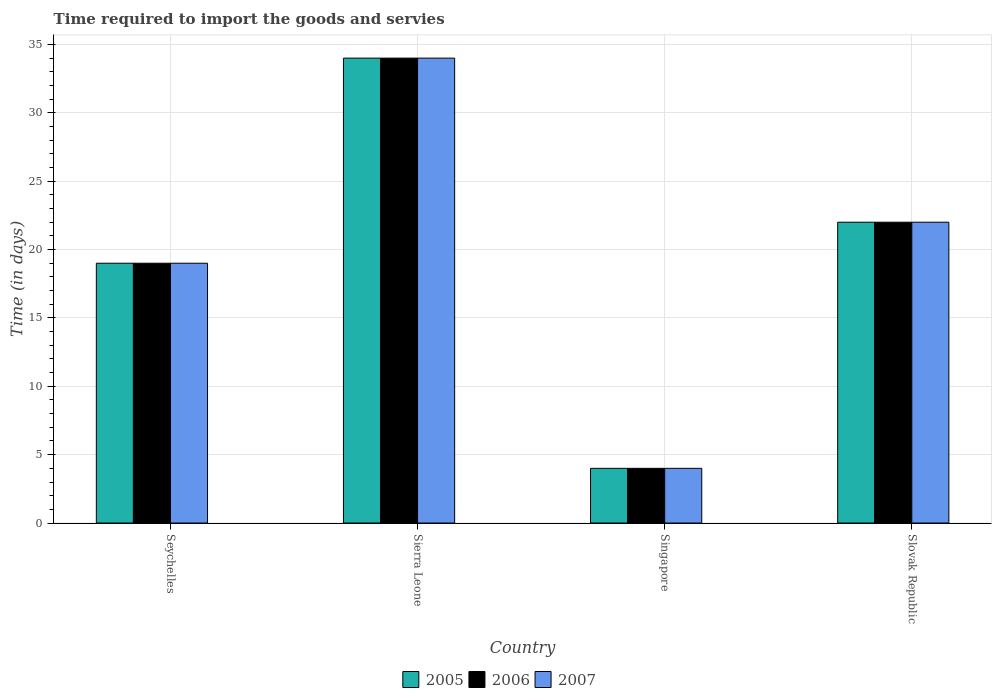How many different coloured bars are there?
Keep it short and to the point. 3. How many groups of bars are there?
Give a very brief answer. 4. Are the number of bars on each tick of the X-axis equal?
Provide a short and direct response. Yes. How many bars are there on the 4th tick from the left?
Your response must be concise. 3. How many bars are there on the 2nd tick from the right?
Offer a terse response. 3. What is the label of the 1st group of bars from the left?
Provide a short and direct response. Seychelles. What is the number of days required to import the goods and services in 2006 in Seychelles?
Provide a short and direct response. 19. Across all countries, what is the maximum number of days required to import the goods and services in 2005?
Ensure brevity in your answer.  34. In which country was the number of days required to import the goods and services in 2005 maximum?
Provide a succinct answer. Sierra Leone. In which country was the number of days required to import the goods and services in 2006 minimum?
Give a very brief answer. Singapore. What is the total number of days required to import the goods and services in 2006 in the graph?
Provide a succinct answer. 79. What is the difference between the number of days required to import the goods and services in 2007 in Sierra Leone and that in Slovak Republic?
Ensure brevity in your answer.  12. What is the average number of days required to import the goods and services in 2005 per country?
Provide a short and direct response. 19.75. What is the difference between the number of days required to import the goods and services of/in 2006 and number of days required to import the goods and services of/in 2007 in Slovak Republic?
Offer a very short reply. 0. In how many countries, is the number of days required to import the goods and services in 2006 greater than 10 days?
Give a very brief answer. 3. What is the ratio of the number of days required to import the goods and services in 2006 in Singapore to that in Slovak Republic?
Offer a terse response. 0.18. Is the difference between the number of days required to import the goods and services in 2006 in Seychelles and Slovak Republic greater than the difference between the number of days required to import the goods and services in 2007 in Seychelles and Slovak Republic?
Make the answer very short. No. What is the difference between the highest and the lowest number of days required to import the goods and services in 2007?
Offer a very short reply. 30. Is it the case that in every country, the sum of the number of days required to import the goods and services in 2005 and number of days required to import the goods and services in 2007 is greater than the number of days required to import the goods and services in 2006?
Your answer should be compact. Yes. How many bars are there?
Your response must be concise. 12. Does the graph contain any zero values?
Offer a terse response. No. Does the graph contain grids?
Ensure brevity in your answer.  Yes. How are the legend labels stacked?
Make the answer very short. Horizontal. What is the title of the graph?
Your answer should be very brief. Time required to import the goods and servies. Does "1970" appear as one of the legend labels in the graph?
Give a very brief answer. No. What is the label or title of the X-axis?
Give a very brief answer. Country. What is the label or title of the Y-axis?
Keep it short and to the point. Time (in days). What is the Time (in days) of 2007 in Seychelles?
Provide a short and direct response. 19. What is the Time (in days) in 2006 in Sierra Leone?
Your response must be concise. 34. What is the Time (in days) of 2005 in Slovak Republic?
Make the answer very short. 22. Across all countries, what is the maximum Time (in days) in 2005?
Offer a terse response. 34. Across all countries, what is the maximum Time (in days) in 2007?
Make the answer very short. 34. Across all countries, what is the minimum Time (in days) in 2005?
Give a very brief answer. 4. Across all countries, what is the minimum Time (in days) of 2006?
Your answer should be very brief. 4. Across all countries, what is the minimum Time (in days) of 2007?
Provide a succinct answer. 4. What is the total Time (in days) of 2005 in the graph?
Your answer should be very brief. 79. What is the total Time (in days) in 2006 in the graph?
Keep it short and to the point. 79. What is the total Time (in days) in 2007 in the graph?
Keep it short and to the point. 79. What is the difference between the Time (in days) in 2005 in Seychelles and that in Sierra Leone?
Ensure brevity in your answer.  -15. What is the difference between the Time (in days) in 2006 in Seychelles and that in Sierra Leone?
Make the answer very short. -15. What is the difference between the Time (in days) in 2005 in Seychelles and that in Singapore?
Offer a terse response. 15. What is the difference between the Time (in days) of 2006 in Seychelles and that in Singapore?
Offer a very short reply. 15. What is the difference between the Time (in days) of 2007 in Seychelles and that in Singapore?
Ensure brevity in your answer.  15. What is the difference between the Time (in days) in 2005 in Seychelles and that in Slovak Republic?
Your answer should be compact. -3. What is the difference between the Time (in days) of 2005 in Sierra Leone and that in Singapore?
Offer a terse response. 30. What is the difference between the Time (in days) of 2006 in Sierra Leone and that in Singapore?
Ensure brevity in your answer.  30. What is the difference between the Time (in days) of 2005 in Sierra Leone and that in Slovak Republic?
Keep it short and to the point. 12. What is the difference between the Time (in days) in 2007 in Singapore and that in Slovak Republic?
Ensure brevity in your answer.  -18. What is the difference between the Time (in days) of 2005 in Seychelles and the Time (in days) of 2007 in Sierra Leone?
Keep it short and to the point. -15. What is the difference between the Time (in days) of 2005 in Seychelles and the Time (in days) of 2006 in Singapore?
Offer a terse response. 15. What is the difference between the Time (in days) in 2005 in Seychelles and the Time (in days) in 2007 in Singapore?
Keep it short and to the point. 15. What is the difference between the Time (in days) of 2006 in Seychelles and the Time (in days) of 2007 in Singapore?
Make the answer very short. 15. What is the difference between the Time (in days) in 2005 in Seychelles and the Time (in days) in 2007 in Slovak Republic?
Your answer should be compact. -3. What is the difference between the Time (in days) of 2006 in Seychelles and the Time (in days) of 2007 in Slovak Republic?
Your answer should be compact. -3. What is the difference between the Time (in days) in 2005 in Sierra Leone and the Time (in days) in 2006 in Slovak Republic?
Provide a succinct answer. 12. What is the difference between the Time (in days) of 2005 in Singapore and the Time (in days) of 2007 in Slovak Republic?
Ensure brevity in your answer.  -18. What is the average Time (in days) of 2005 per country?
Your answer should be compact. 19.75. What is the average Time (in days) in 2006 per country?
Your answer should be compact. 19.75. What is the average Time (in days) in 2007 per country?
Offer a very short reply. 19.75. What is the difference between the Time (in days) in 2006 and Time (in days) in 2007 in Seychelles?
Give a very brief answer. 0. What is the difference between the Time (in days) in 2005 and Time (in days) in 2007 in Sierra Leone?
Offer a terse response. 0. What is the difference between the Time (in days) of 2006 and Time (in days) of 2007 in Sierra Leone?
Your response must be concise. 0. What is the difference between the Time (in days) of 2005 and Time (in days) of 2007 in Singapore?
Your answer should be compact. 0. What is the difference between the Time (in days) in 2006 and Time (in days) in 2007 in Singapore?
Offer a very short reply. 0. What is the difference between the Time (in days) of 2005 and Time (in days) of 2007 in Slovak Republic?
Provide a succinct answer. 0. What is the difference between the Time (in days) of 2006 and Time (in days) of 2007 in Slovak Republic?
Offer a very short reply. 0. What is the ratio of the Time (in days) of 2005 in Seychelles to that in Sierra Leone?
Your answer should be very brief. 0.56. What is the ratio of the Time (in days) in 2006 in Seychelles to that in Sierra Leone?
Make the answer very short. 0.56. What is the ratio of the Time (in days) of 2007 in Seychelles to that in Sierra Leone?
Your answer should be compact. 0.56. What is the ratio of the Time (in days) of 2005 in Seychelles to that in Singapore?
Offer a very short reply. 4.75. What is the ratio of the Time (in days) in 2006 in Seychelles to that in Singapore?
Offer a terse response. 4.75. What is the ratio of the Time (in days) in 2007 in Seychelles to that in Singapore?
Offer a very short reply. 4.75. What is the ratio of the Time (in days) of 2005 in Seychelles to that in Slovak Republic?
Your answer should be compact. 0.86. What is the ratio of the Time (in days) of 2006 in Seychelles to that in Slovak Republic?
Your response must be concise. 0.86. What is the ratio of the Time (in days) in 2007 in Seychelles to that in Slovak Republic?
Keep it short and to the point. 0.86. What is the ratio of the Time (in days) in 2005 in Sierra Leone to that in Slovak Republic?
Provide a succinct answer. 1.55. What is the ratio of the Time (in days) in 2006 in Sierra Leone to that in Slovak Republic?
Your answer should be compact. 1.55. What is the ratio of the Time (in days) of 2007 in Sierra Leone to that in Slovak Republic?
Your answer should be compact. 1.55. What is the ratio of the Time (in days) in 2005 in Singapore to that in Slovak Republic?
Your answer should be very brief. 0.18. What is the ratio of the Time (in days) in 2006 in Singapore to that in Slovak Republic?
Give a very brief answer. 0.18. What is the ratio of the Time (in days) in 2007 in Singapore to that in Slovak Republic?
Provide a succinct answer. 0.18. What is the difference between the highest and the second highest Time (in days) of 2005?
Keep it short and to the point. 12. What is the difference between the highest and the second highest Time (in days) in 2006?
Your answer should be very brief. 12. What is the difference between the highest and the lowest Time (in days) in 2005?
Your response must be concise. 30. 